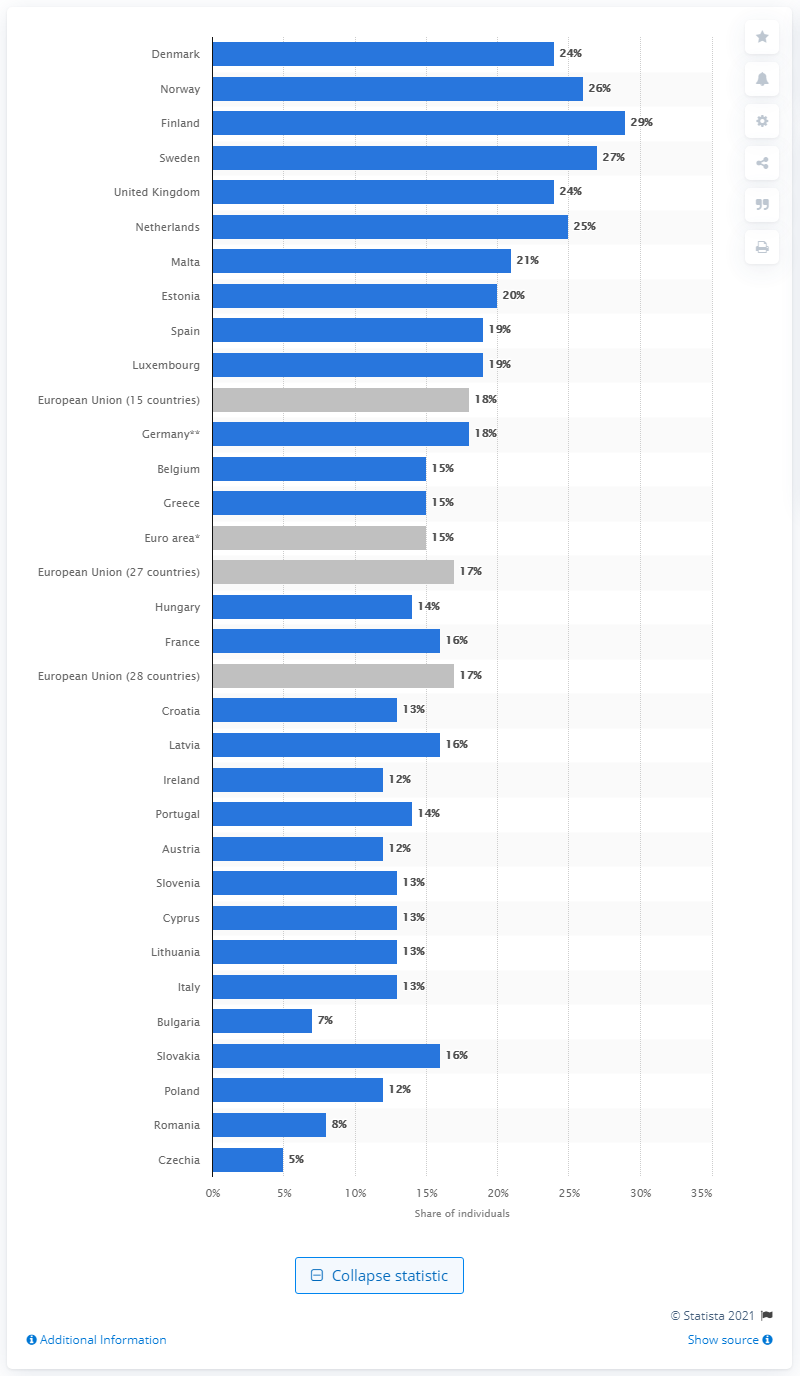Mention a couple of crucial points in this snapshot. According to the data, the highest usage of the internet for job search and application was in Finland. 